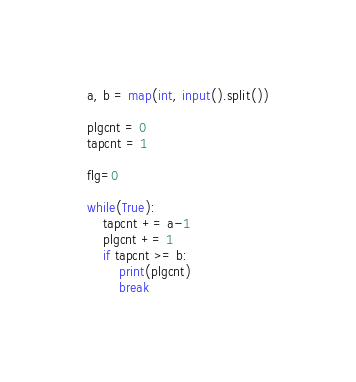Convert code to text. <code><loc_0><loc_0><loc_500><loc_500><_Python_>a, b = map(int, input().split())

plgcnt = 0
tapcnt = 1

flg=0

while(True):
    tapcnt += a-1
    plgcnt += 1
    if tapcnt >= b:
        print(plgcnt)
        break
</code> 